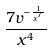Convert formula to latex. <formula><loc_0><loc_0><loc_500><loc_500>\frac { 7 v ^ { - \frac { 1 } { x ^ { 7 } } } } { x ^ { 4 } }</formula> 